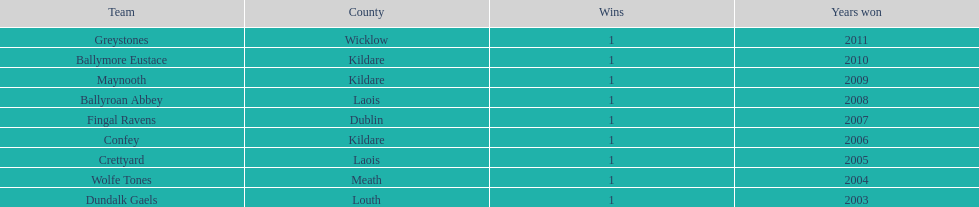How many triumphs has greystones achieved? 1. 